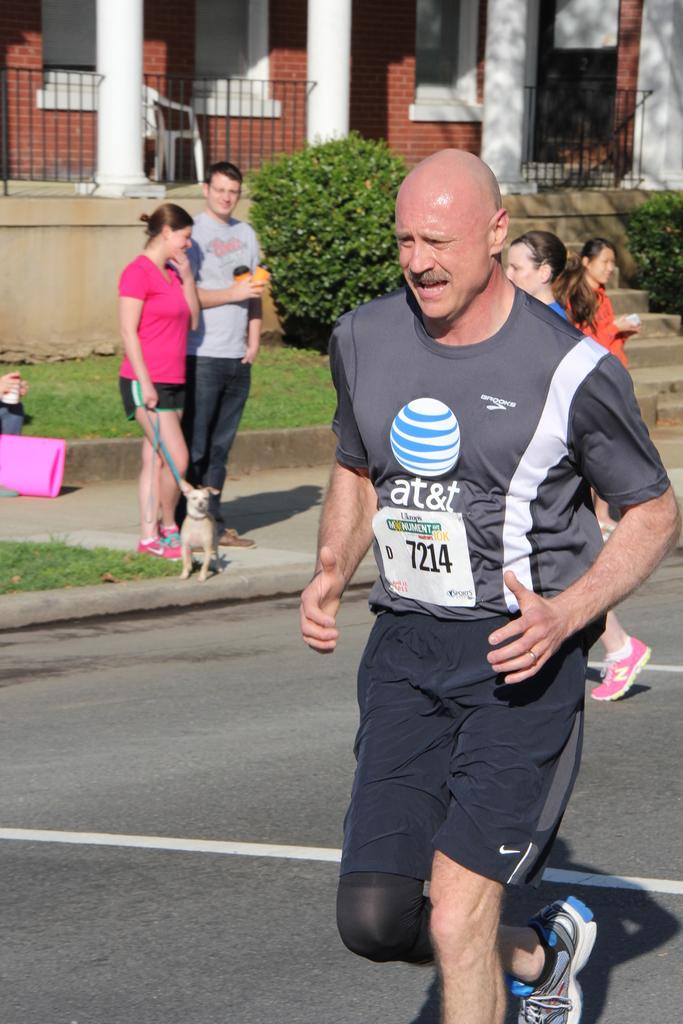What is the man in the image doing? The man is running on the road. What can be seen in the background of the image? There are persons, a dog, grass, plants, pillars, a wall, windows, and objects visible in the background. What type of structure is visible in the background? The image shows pillars and a wall in the background. What is the man running on? The man is running on the road, which has grass on the ground. What is the purpose of the railing visible in the image? The railing is likely there for safety or to prevent people from falling off the road or path. How does the man compare his attention span to the dog's in the image? There is no information in the image about the man's or the dog's attention span, so it cannot be determined from the image. What is in the man's pocket in the image? There is no information about the man's pocket or its contents in the image. 